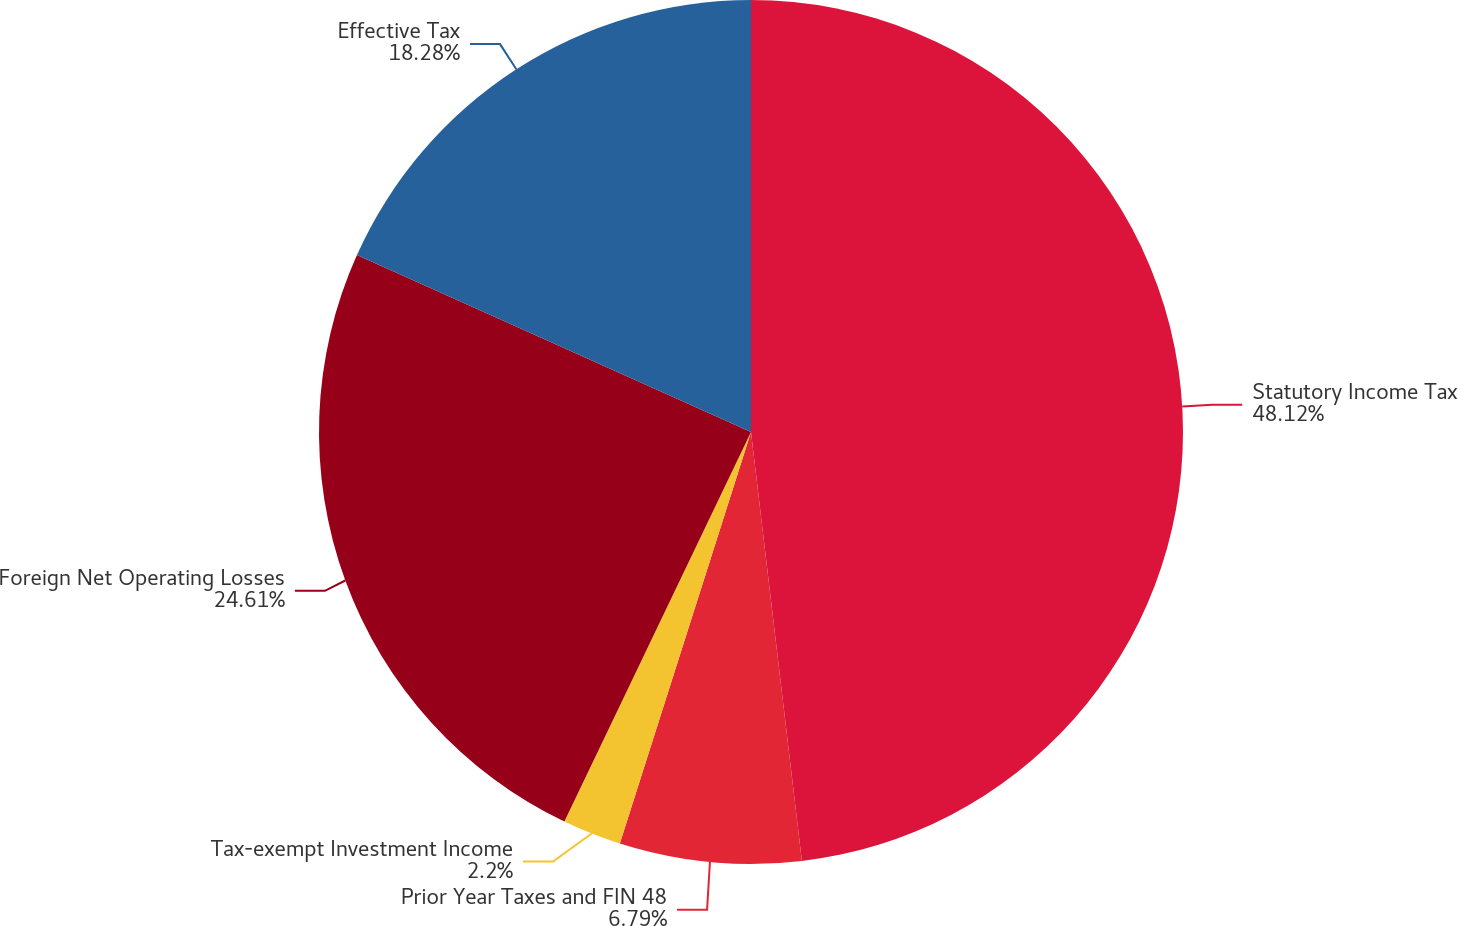Convert chart to OTSL. <chart><loc_0><loc_0><loc_500><loc_500><pie_chart><fcel>Statutory Income Tax<fcel>Prior Year Taxes and FIN 48<fcel>Tax-exempt Investment Income<fcel>Foreign Net Operating Losses<fcel>Effective Tax<nl><fcel>48.12%<fcel>6.79%<fcel>2.2%<fcel>24.61%<fcel>18.28%<nl></chart> 